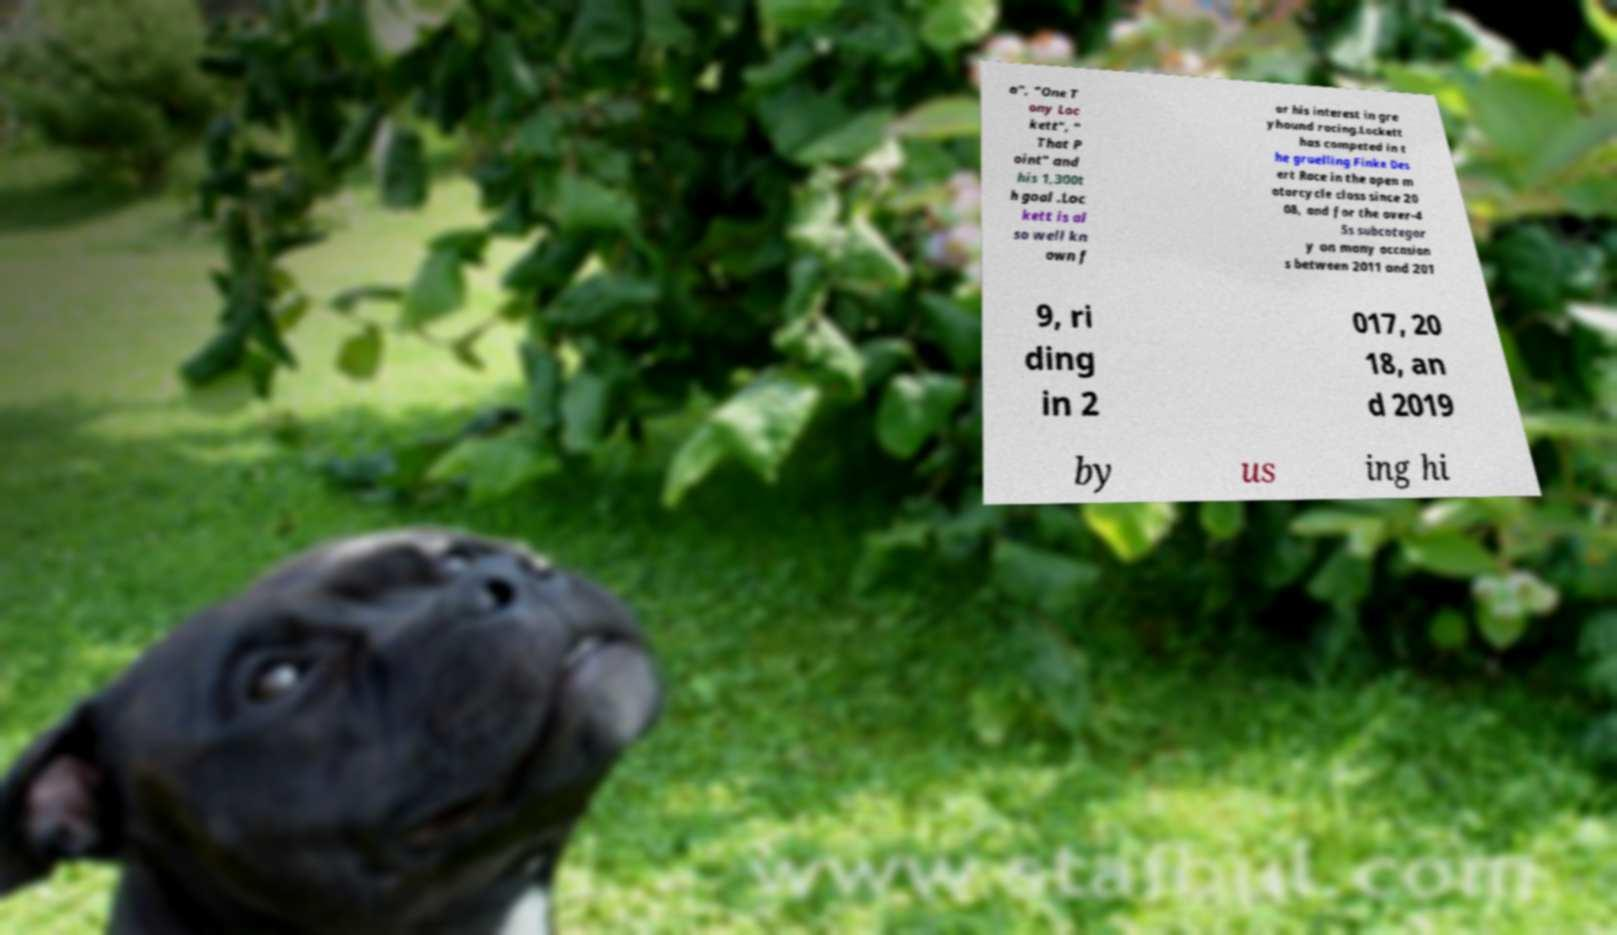Could you assist in decoding the text presented in this image and type it out clearly? a", "One T ony Loc kett", " That P oint" and his 1,300t h goal .Loc kett is al so well kn own f or his interest in gre yhound racing.Lockett has competed in t he gruelling Finke Des ert Race in the open m otorcycle class since 20 08, and for the over-4 5s subcategor y on many occasion s between 2011 and 201 9, ri ding in 2 017, 20 18, an d 2019 by us ing hi 